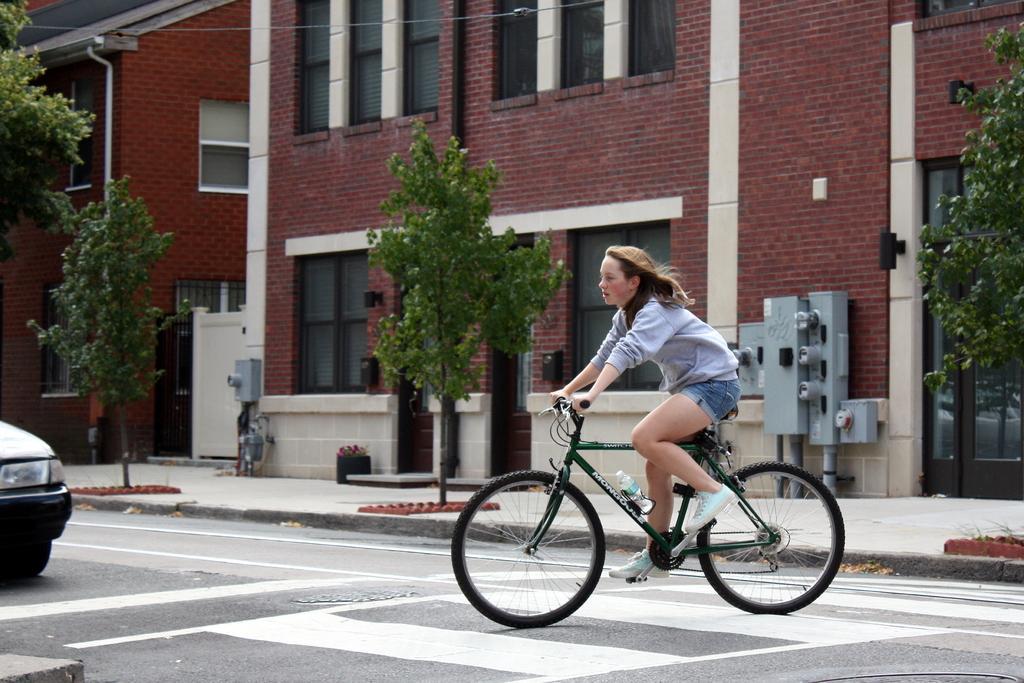Could you give a brief overview of what you see in this image? In this picture a lady is riding a bicycle on a zebra crossing. There is also a vehicle on the left side of the image. 